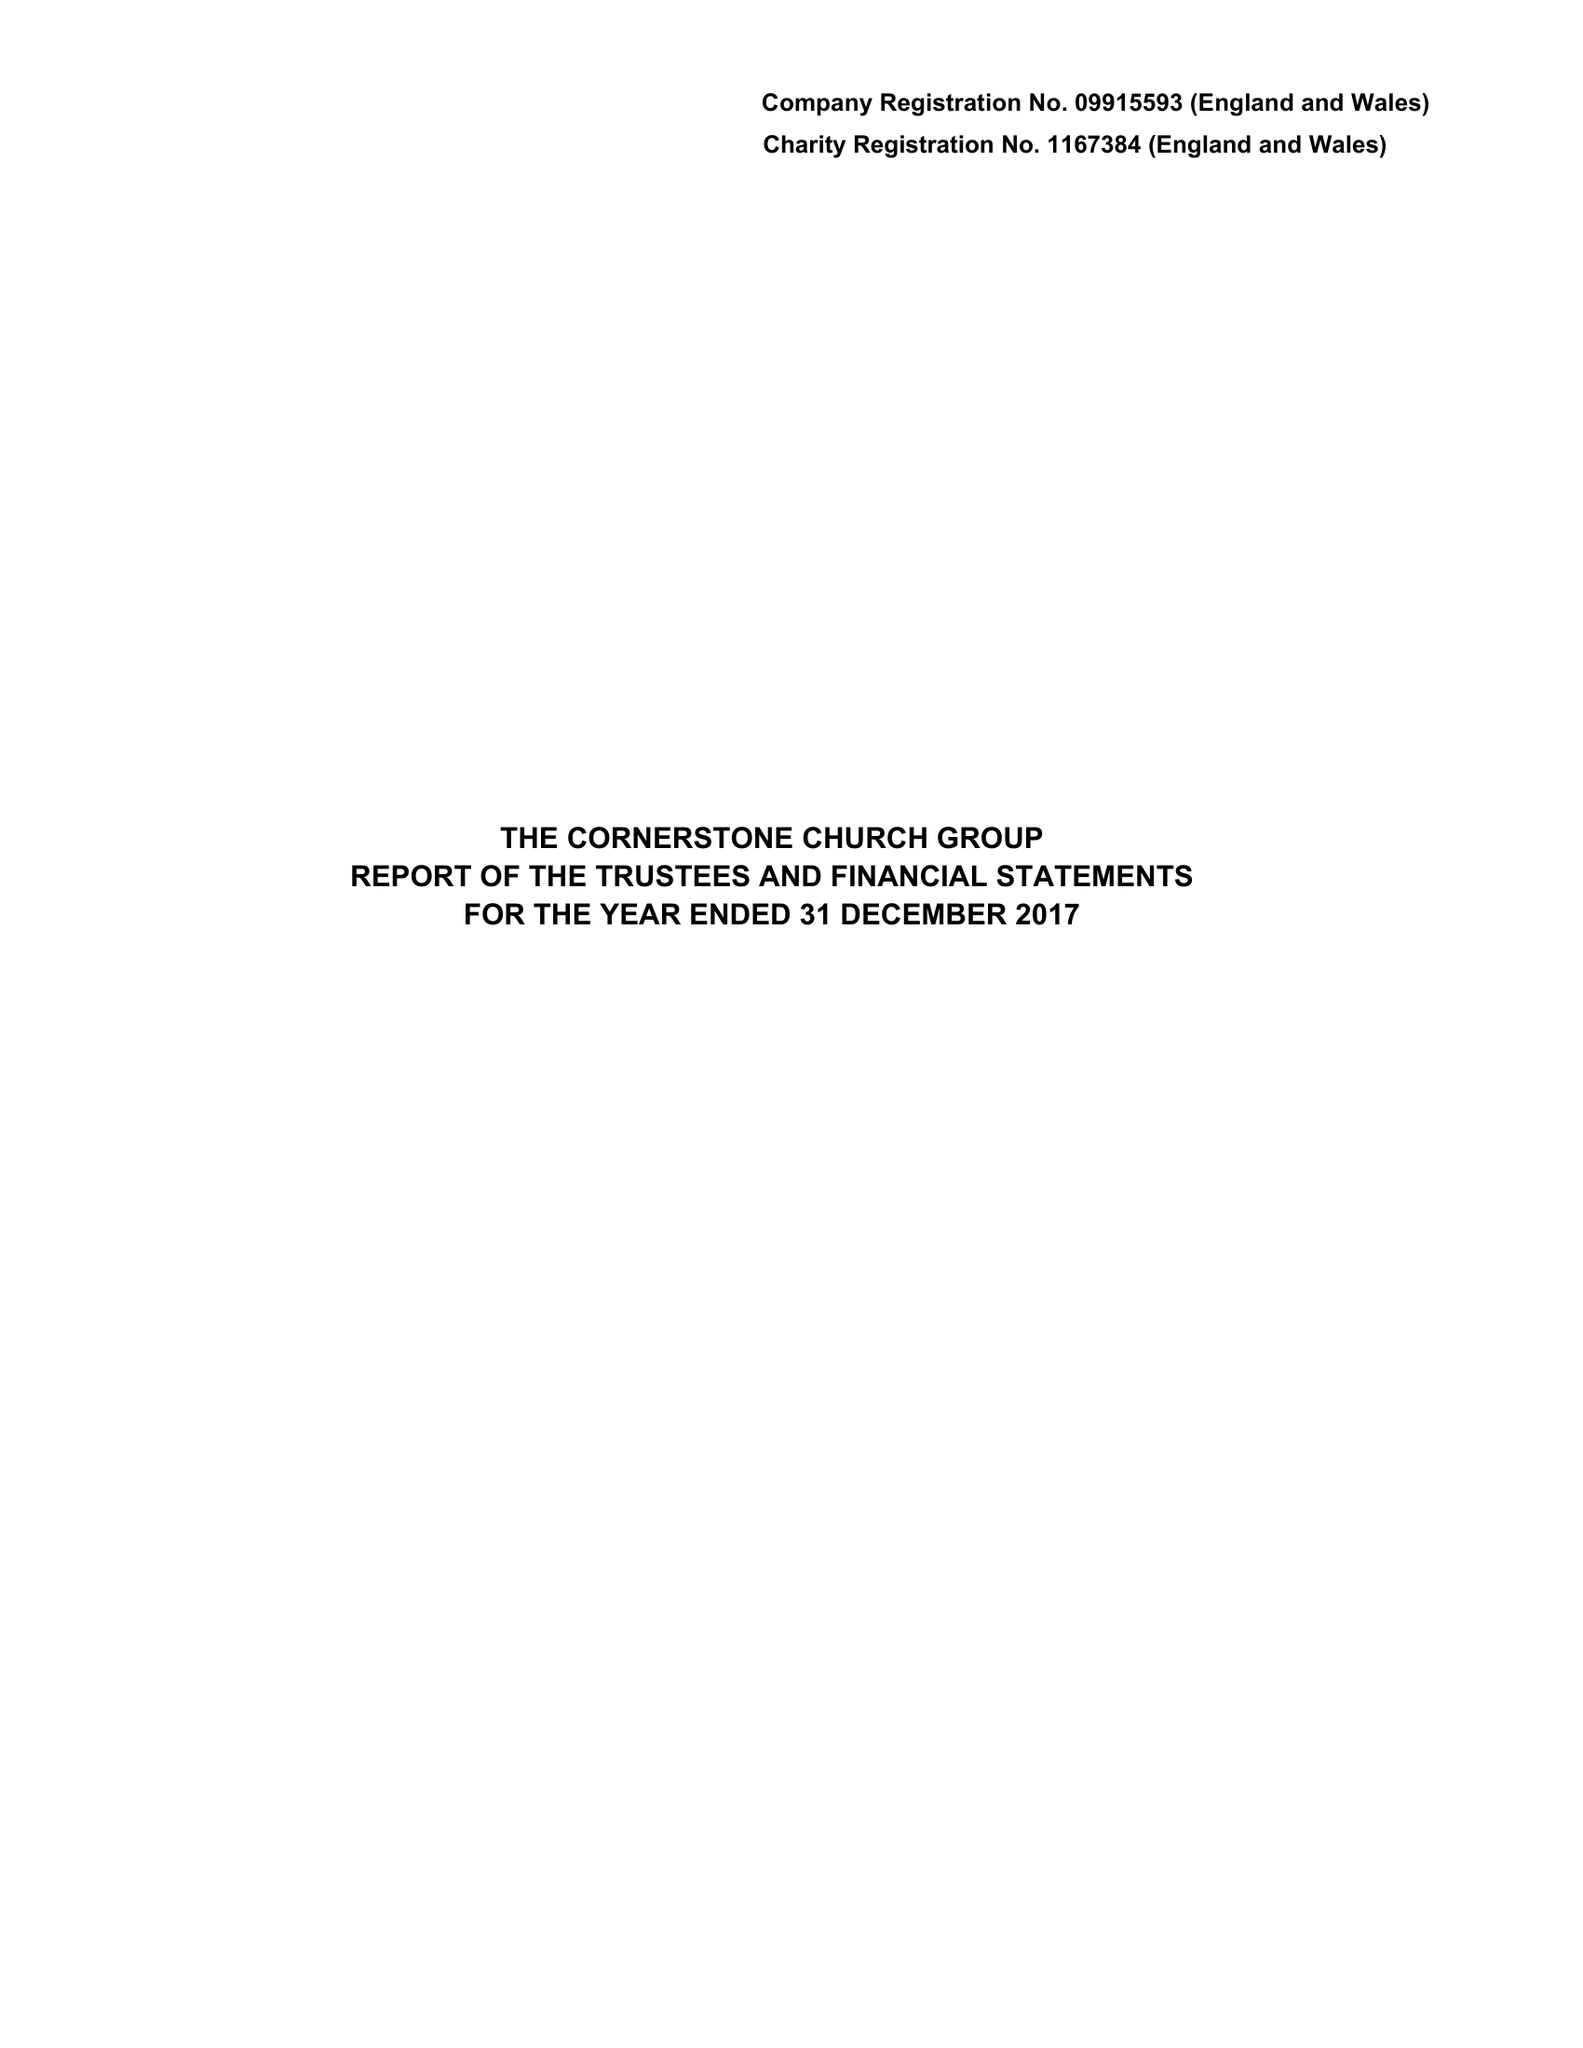What is the value for the charity_name?
Answer the question using a single word or phrase. The Cornerstone Church Group 